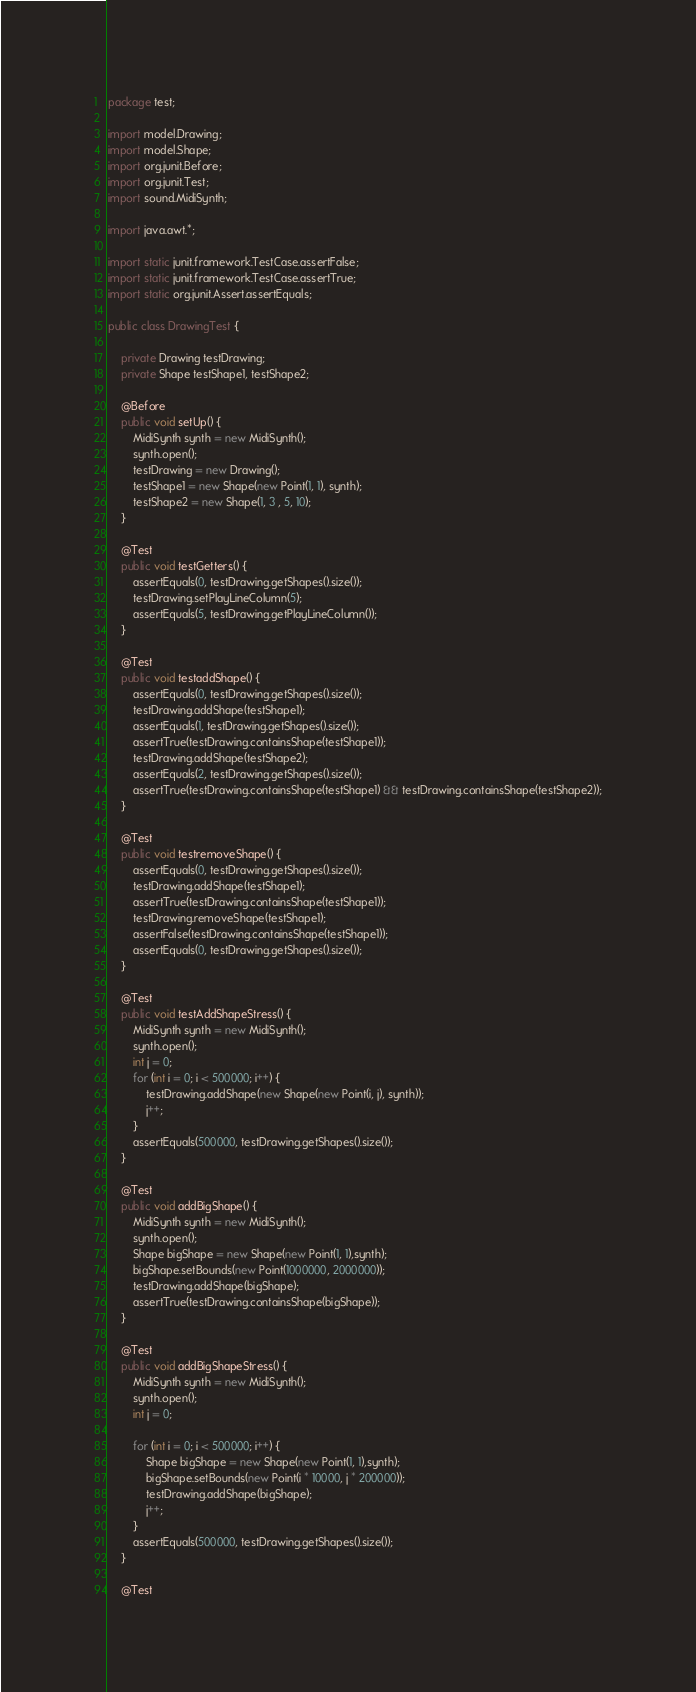<code> <loc_0><loc_0><loc_500><loc_500><_Java_>package test;

import model.Drawing;
import model.Shape;
import org.junit.Before;
import org.junit.Test;
import sound.MidiSynth;

import java.awt.*;

import static junit.framework.TestCase.assertFalse;
import static junit.framework.TestCase.assertTrue;
import static org.junit.Assert.assertEquals;

public class DrawingTest {

    private Drawing testDrawing;
    private Shape testShape1, testShape2;

    @Before
    public void setUp() {
        MidiSynth synth = new MidiSynth();
        synth.open();
        testDrawing = new Drawing();
        testShape1 = new Shape(new Point(1, 1), synth);
        testShape2 = new Shape(1, 3 , 5, 10);
    }

    @Test
    public void testGetters() {
        assertEquals(0, testDrawing.getShapes().size());
        testDrawing.setPlayLineColumn(5);
        assertEquals(5, testDrawing.getPlayLineColumn());
    }

    @Test
    public void testaddShape() {
        assertEquals(0, testDrawing.getShapes().size());
        testDrawing.addShape(testShape1);
        assertEquals(1, testDrawing.getShapes().size());
        assertTrue(testDrawing.containsShape(testShape1));
        testDrawing.addShape(testShape2);
        assertEquals(2, testDrawing.getShapes().size());
        assertTrue(testDrawing.containsShape(testShape1) && testDrawing.containsShape(testShape2));
    }

    @Test
    public void testremoveShape() {
        assertEquals(0, testDrawing.getShapes().size());
        testDrawing.addShape(testShape1);
        assertTrue(testDrawing.containsShape(testShape1));
        testDrawing.removeShape(testShape1);
        assertFalse(testDrawing.containsShape(testShape1));
        assertEquals(0, testDrawing.getShapes().size());
    }

    @Test
    public void testAddShapeStress() {
        MidiSynth synth = new MidiSynth();
        synth.open();
        int j = 0;
        for (int i = 0; i < 500000; i++) {
            testDrawing.addShape(new Shape(new Point(i, j), synth));
            j++;
        }
        assertEquals(500000, testDrawing.getShapes().size());
    }

    @Test
    public void addBigShape() {
        MidiSynth synth = new MidiSynth();
        synth.open();
        Shape bigShape = new Shape(new Point(1, 1),synth);
        bigShape.setBounds(new Point(1000000, 2000000));
        testDrawing.addShape(bigShape);
        assertTrue(testDrawing.containsShape(bigShape));
    }

    @Test
    public void addBigShapeStress() {
        MidiSynth synth = new MidiSynth();
        synth.open();
        int j = 0;

        for (int i = 0; i < 500000; i++) {
            Shape bigShape = new Shape(new Point(1, 1),synth);
            bigShape.setBounds(new Point(i * 10000, j * 200000));
            testDrawing.addShape(bigShape);
            j++;
        }
        assertEquals(500000, testDrawing.getShapes().size());
    }

    @Test</code> 